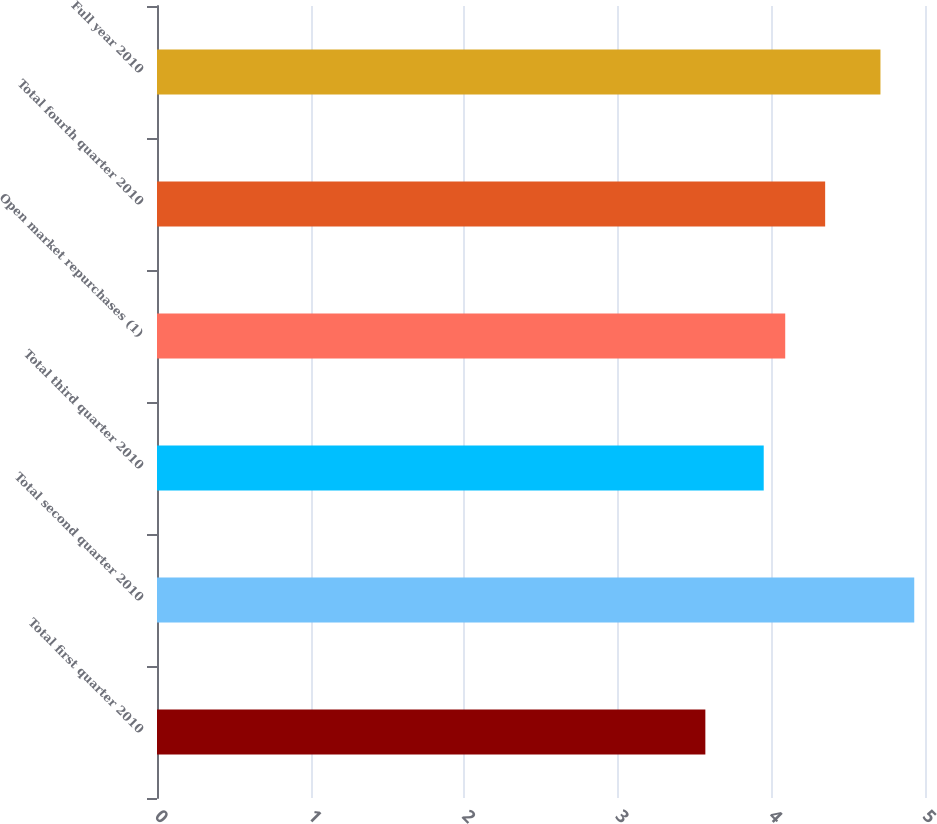Convert chart to OTSL. <chart><loc_0><loc_0><loc_500><loc_500><bar_chart><fcel>Total first quarter 2010<fcel>Total second quarter 2010<fcel>Total third quarter 2010<fcel>Open market repurchases (1)<fcel>Total fourth quarter 2010<fcel>Full year 2010<nl><fcel>3.57<fcel>4.93<fcel>3.95<fcel>4.09<fcel>4.35<fcel>4.71<nl></chart> 